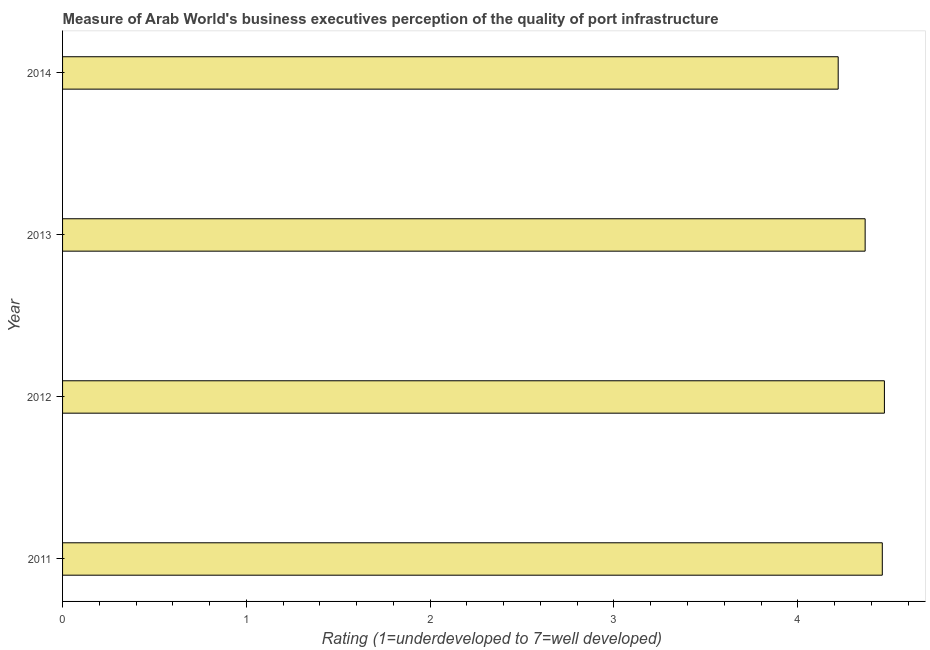Does the graph contain any zero values?
Offer a terse response. No. What is the title of the graph?
Offer a very short reply. Measure of Arab World's business executives perception of the quality of port infrastructure. What is the label or title of the X-axis?
Your response must be concise. Rating (1=underdeveloped to 7=well developed) . What is the rating measuring quality of port infrastructure in 2012?
Provide a succinct answer. 4.47. Across all years, what is the maximum rating measuring quality of port infrastructure?
Offer a very short reply. 4.47. Across all years, what is the minimum rating measuring quality of port infrastructure?
Offer a terse response. 4.22. In which year was the rating measuring quality of port infrastructure maximum?
Make the answer very short. 2012. What is the sum of the rating measuring quality of port infrastructure?
Ensure brevity in your answer.  17.52. What is the difference between the rating measuring quality of port infrastructure in 2011 and 2014?
Give a very brief answer. 0.24. What is the average rating measuring quality of port infrastructure per year?
Keep it short and to the point. 4.38. What is the median rating measuring quality of port infrastructure?
Offer a very short reply. 4.41. What is the ratio of the rating measuring quality of port infrastructure in 2011 to that in 2012?
Keep it short and to the point. 1. Is the difference between the rating measuring quality of port infrastructure in 2012 and 2014 greater than the difference between any two years?
Make the answer very short. Yes. What is the difference between the highest and the second highest rating measuring quality of port infrastructure?
Ensure brevity in your answer.  0.01. What is the difference between the highest and the lowest rating measuring quality of port infrastructure?
Ensure brevity in your answer.  0.25. In how many years, is the rating measuring quality of port infrastructure greater than the average rating measuring quality of port infrastructure taken over all years?
Your answer should be very brief. 2. Are all the bars in the graph horizontal?
Offer a terse response. Yes. What is the Rating (1=underdeveloped to 7=well developed)  in 2011?
Offer a very short reply. 4.46. What is the Rating (1=underdeveloped to 7=well developed)  in 2012?
Ensure brevity in your answer.  4.47. What is the Rating (1=underdeveloped to 7=well developed)  of 2013?
Your answer should be compact. 4.37. What is the Rating (1=underdeveloped to 7=well developed)  of 2014?
Your answer should be very brief. 4.22. What is the difference between the Rating (1=underdeveloped to 7=well developed)  in 2011 and 2012?
Your answer should be very brief. -0.01. What is the difference between the Rating (1=underdeveloped to 7=well developed)  in 2011 and 2013?
Provide a succinct answer. 0.09. What is the difference between the Rating (1=underdeveloped to 7=well developed)  in 2011 and 2014?
Provide a short and direct response. 0.24. What is the difference between the Rating (1=underdeveloped to 7=well developed)  in 2012 and 2013?
Make the answer very short. 0.1. What is the difference between the Rating (1=underdeveloped to 7=well developed)  in 2012 and 2014?
Ensure brevity in your answer.  0.25. What is the difference between the Rating (1=underdeveloped to 7=well developed)  in 2013 and 2014?
Give a very brief answer. 0.15. What is the ratio of the Rating (1=underdeveloped to 7=well developed)  in 2011 to that in 2012?
Your answer should be very brief. 1. What is the ratio of the Rating (1=underdeveloped to 7=well developed)  in 2011 to that in 2014?
Your answer should be very brief. 1.06. What is the ratio of the Rating (1=underdeveloped to 7=well developed)  in 2012 to that in 2014?
Provide a short and direct response. 1.06. What is the ratio of the Rating (1=underdeveloped to 7=well developed)  in 2013 to that in 2014?
Give a very brief answer. 1.03. 